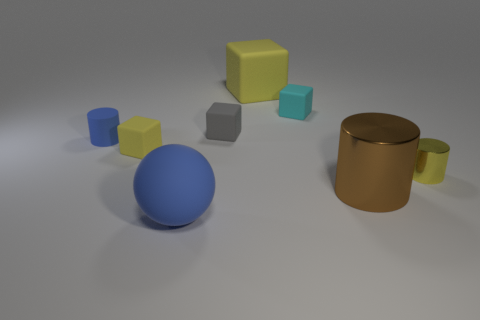There is a yellow rubber cube on the left side of the blue sphere; is its size the same as the blue matte sphere?
Keep it short and to the point. No. What is the size of the matte object that is the same shape as the tiny metal thing?
Your answer should be very brief. Small. There is a sphere that is the same size as the brown object; what is it made of?
Give a very brief answer. Rubber. There is a tiny yellow thing that is the same shape as the gray rubber thing; what is its material?
Offer a very short reply. Rubber. What number of other objects are the same size as the cyan block?
Your answer should be compact. 4. There is a object that is the same color as the large sphere; what is its size?
Offer a terse response. Small. What number of objects are the same color as the small metallic cylinder?
Your answer should be very brief. 2. What is the shape of the gray thing?
Give a very brief answer. Cube. What is the color of the thing that is left of the large blue matte object and right of the blue matte cylinder?
Offer a very short reply. Yellow. What is the blue cylinder made of?
Provide a succinct answer. Rubber. 